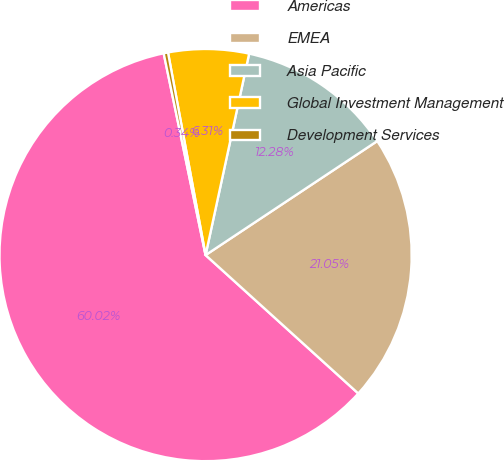Convert chart. <chart><loc_0><loc_0><loc_500><loc_500><pie_chart><fcel>Americas<fcel>EMEA<fcel>Asia Pacific<fcel>Global Investment Management<fcel>Development Services<nl><fcel>60.03%<fcel>21.05%<fcel>12.28%<fcel>6.31%<fcel>0.34%<nl></chart> 